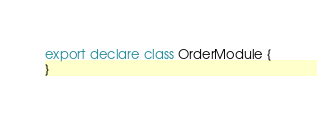<code> <loc_0><loc_0><loc_500><loc_500><_TypeScript_>export declare class OrderModule {
}
</code> 